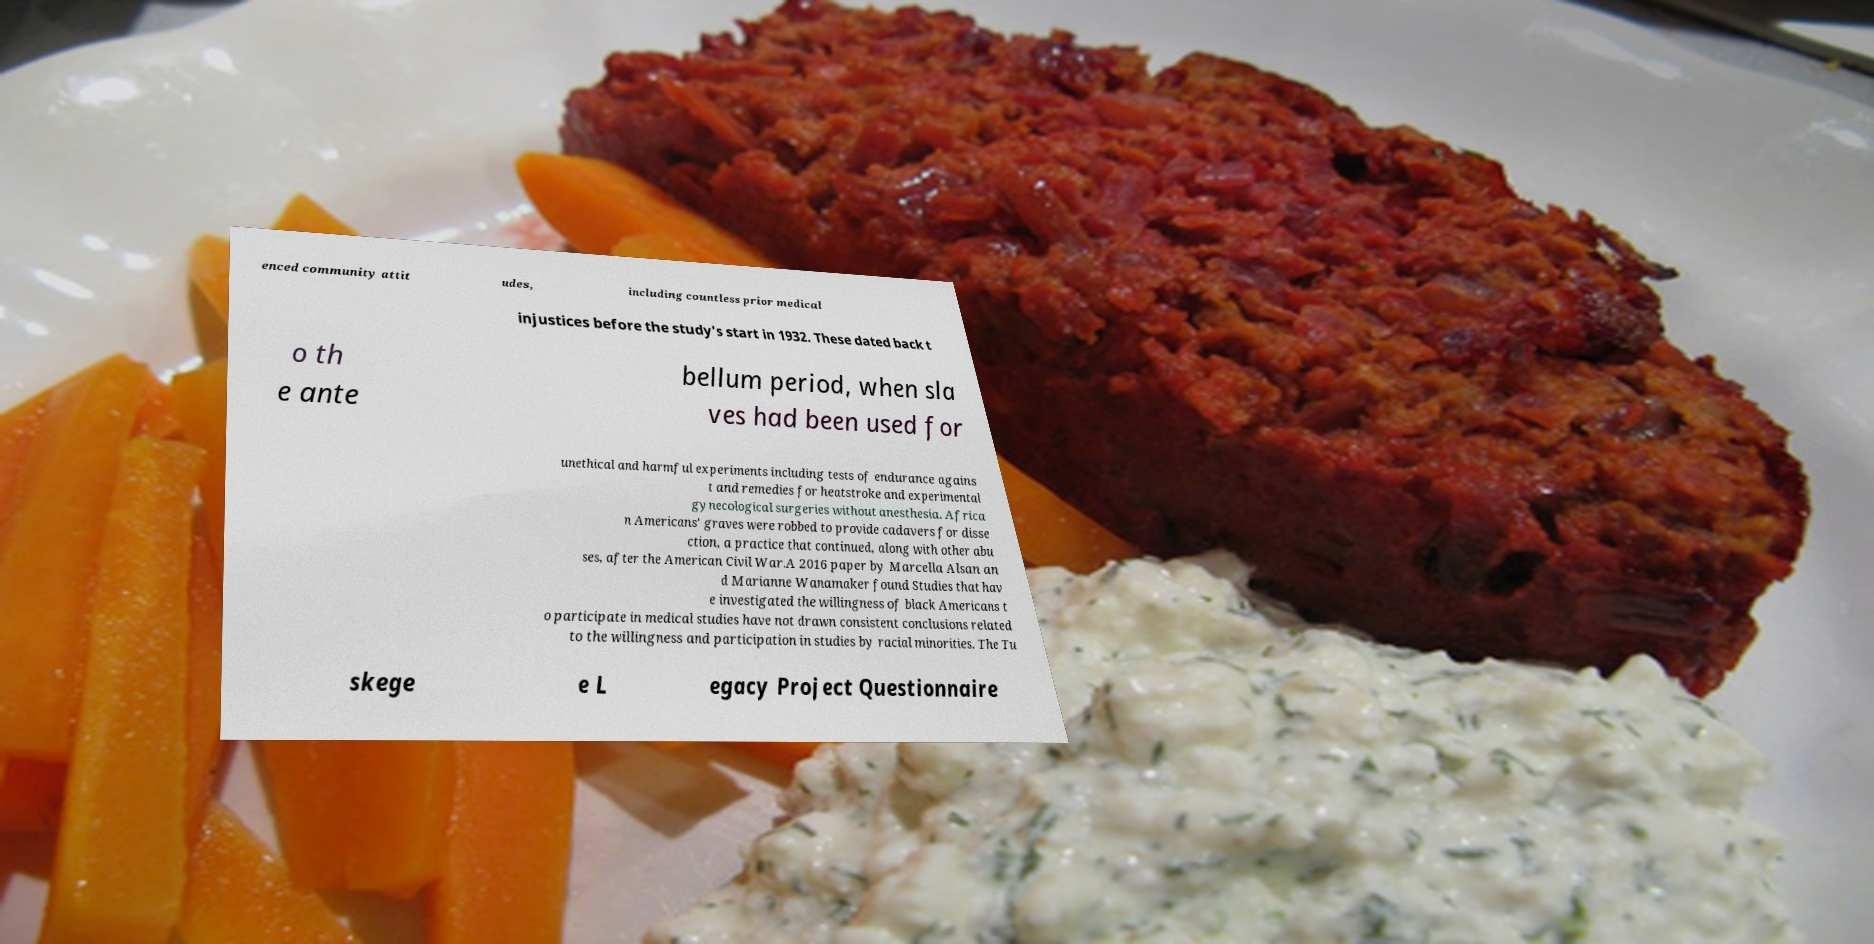For documentation purposes, I need the text within this image transcribed. Could you provide that? enced community attit udes, including countless prior medical injustices before the study's start in 1932. These dated back t o th e ante bellum period, when sla ves had been used for unethical and harmful experiments including tests of endurance agains t and remedies for heatstroke and experimental gynecological surgeries without anesthesia. Africa n Americans' graves were robbed to provide cadavers for disse ction, a practice that continued, along with other abu ses, after the American Civil War.A 2016 paper by Marcella Alsan an d Marianne Wanamaker found Studies that hav e investigated the willingness of black Americans t o participate in medical studies have not drawn consistent conclusions related to the willingness and participation in studies by racial minorities. The Tu skege e L egacy Project Questionnaire 